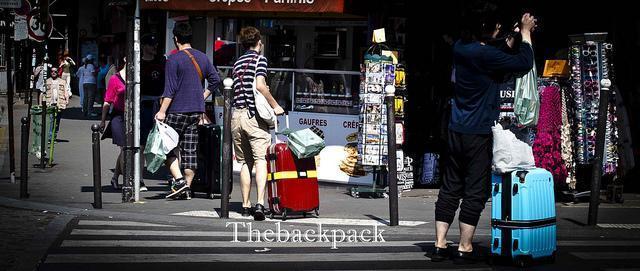How many suitcases can you see?
Give a very brief answer. 2. How many people are there?
Give a very brief answer. 4. 